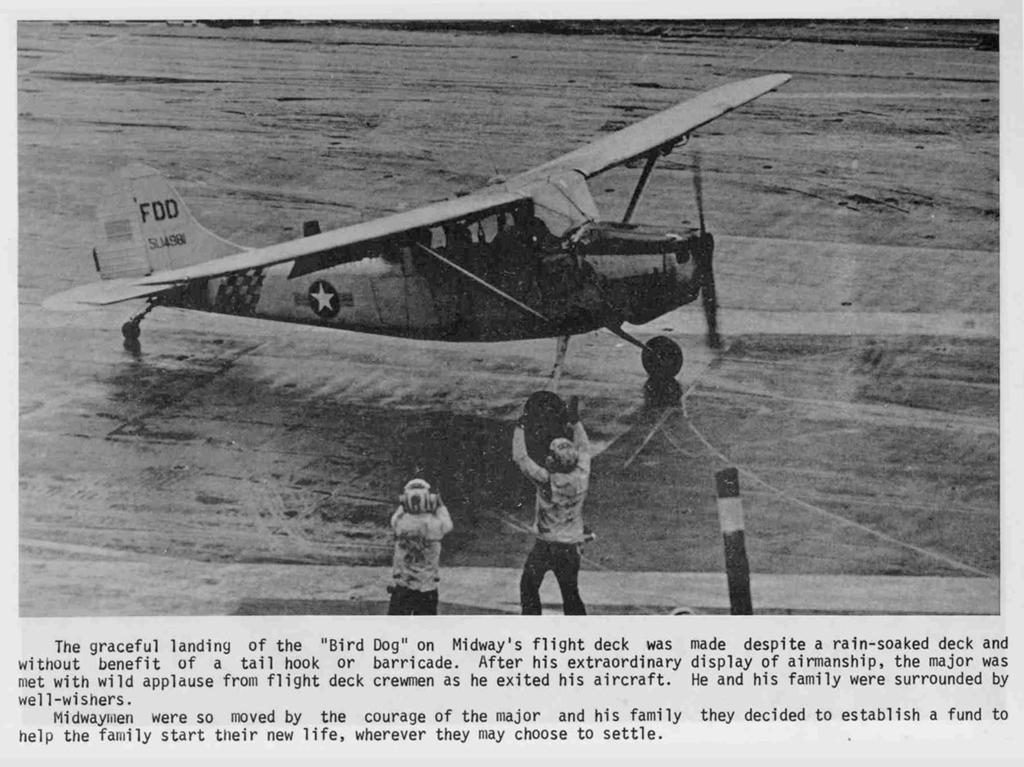What is the main subject of the image? The main subject of the image is an aircraft. How many people are present in the image? There are two people in the image. What can be seen on the aircraft? There is text written on the aircraft. What is the color scheme of the image? The image is in black and white. How many tomatoes are on the card held by one of the people in the image? There are no tomatoes or cards present in the image. 